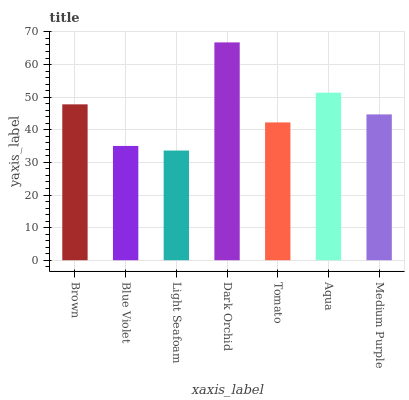Is Blue Violet the minimum?
Answer yes or no. No. Is Blue Violet the maximum?
Answer yes or no. No. Is Brown greater than Blue Violet?
Answer yes or no. Yes. Is Blue Violet less than Brown?
Answer yes or no. Yes. Is Blue Violet greater than Brown?
Answer yes or no. No. Is Brown less than Blue Violet?
Answer yes or no. No. Is Medium Purple the high median?
Answer yes or no. Yes. Is Medium Purple the low median?
Answer yes or no. Yes. Is Tomato the high median?
Answer yes or no. No. Is Light Seafoam the low median?
Answer yes or no. No. 